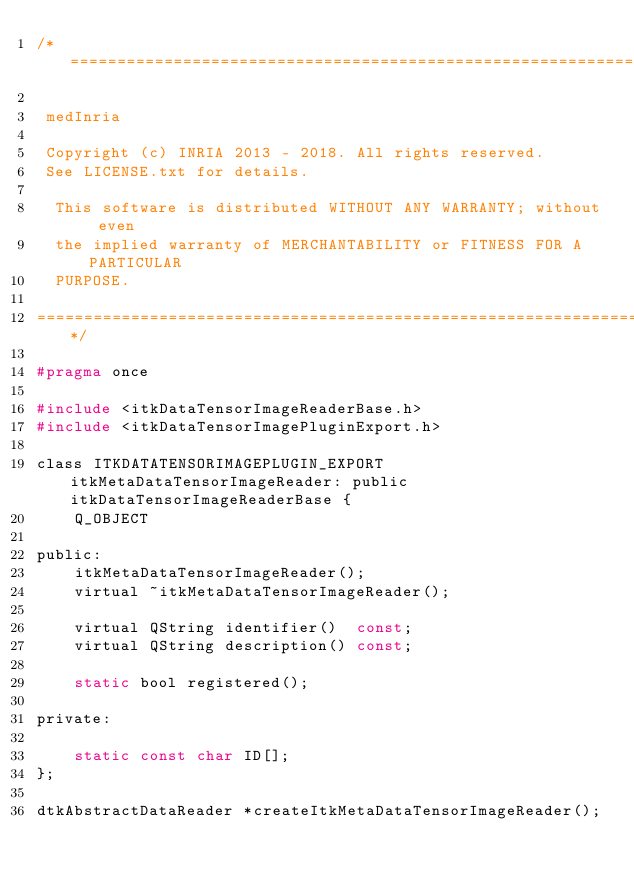<code> <loc_0><loc_0><loc_500><loc_500><_C_>/*=========================================================================

 medInria

 Copyright (c) INRIA 2013 - 2018. All rights reserved.
 See LICENSE.txt for details.
 
  This software is distributed WITHOUT ANY WARRANTY; without even
  the implied warranty of MERCHANTABILITY or FITNESS FOR A PARTICULAR
  PURPOSE.

=========================================================================*/

#pragma once

#include <itkDataTensorImageReaderBase.h>
#include <itkDataTensorImagePluginExport.h>

class ITKDATATENSORIMAGEPLUGIN_EXPORT itkMetaDataTensorImageReader: public itkDataTensorImageReaderBase {
    Q_OBJECT

public:
    itkMetaDataTensorImageReader();
    virtual ~itkMetaDataTensorImageReader();

    virtual QString identifier()  const;
    virtual QString description() const;

    static bool registered();

private:

    static const char ID[];
};

dtkAbstractDataReader *createItkMetaDataTensorImageReader();


</code> 